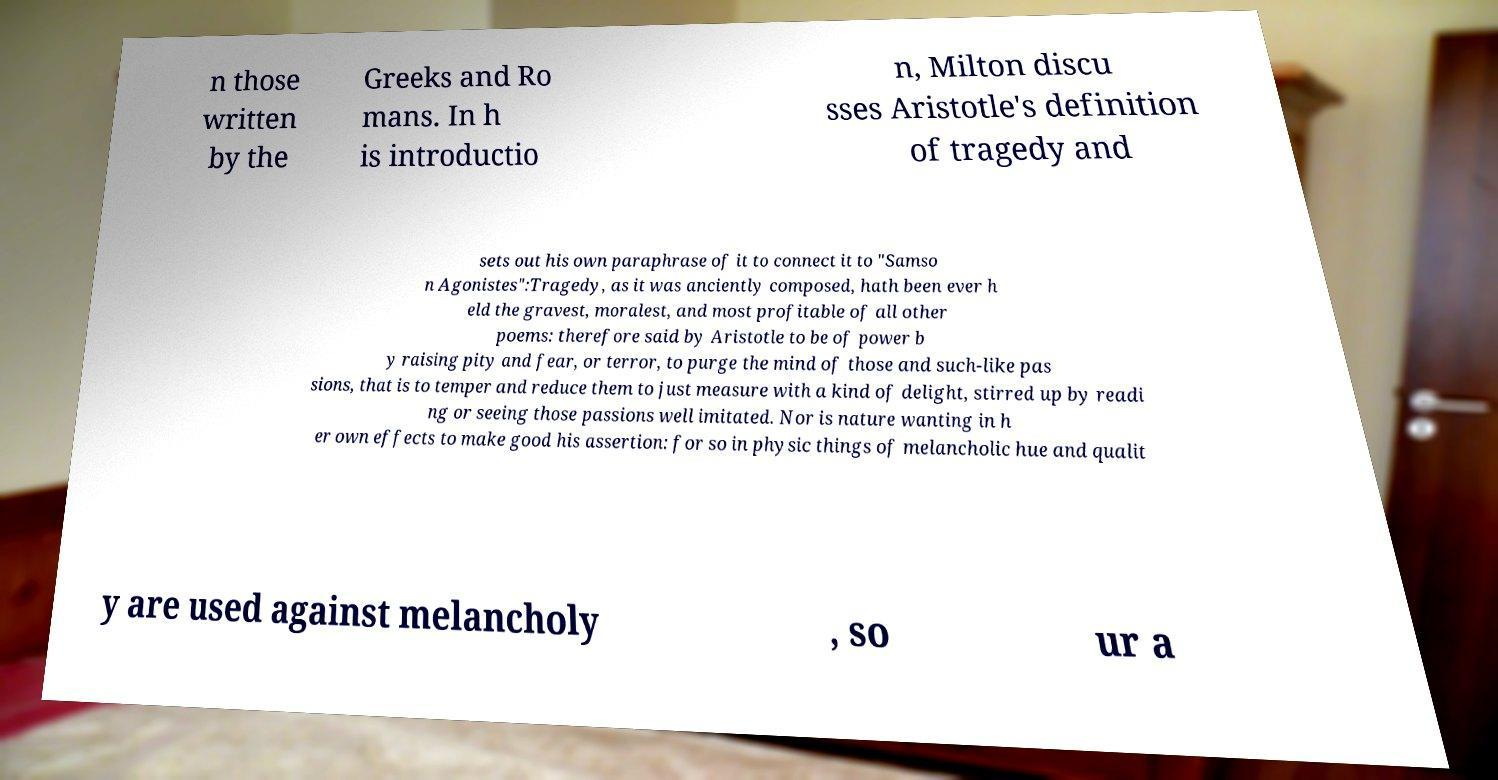Can you read and provide the text displayed in the image?This photo seems to have some interesting text. Can you extract and type it out for me? n those written by the Greeks and Ro mans. In h is introductio n, Milton discu sses Aristotle's definition of tragedy and sets out his own paraphrase of it to connect it to "Samso n Agonistes":Tragedy, as it was anciently composed, hath been ever h eld the gravest, moralest, and most profitable of all other poems: therefore said by Aristotle to be of power b y raising pity and fear, or terror, to purge the mind of those and such-like pas sions, that is to temper and reduce them to just measure with a kind of delight, stirred up by readi ng or seeing those passions well imitated. Nor is nature wanting in h er own effects to make good his assertion: for so in physic things of melancholic hue and qualit y are used against melancholy , so ur a 